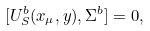<formula> <loc_0><loc_0><loc_500><loc_500>[ U _ { S } ^ { b } ( x _ { \mu } , y ) , \Sigma ^ { b } ] = 0 ,</formula> 